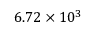<formula> <loc_0><loc_0><loc_500><loc_500>6 . 7 2 \times 1 0 ^ { 3 }</formula> 